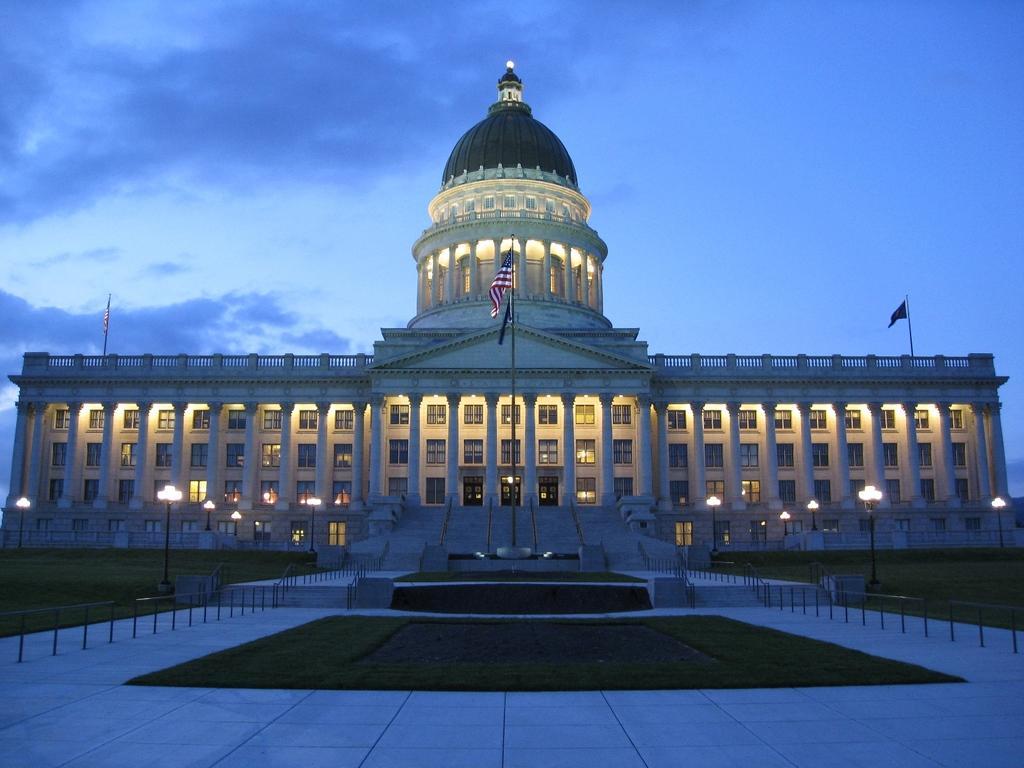Please provide a concise description of this image. In the image we can see there is a ground covered with grass and there are stairs. There is a building and there are street light poles. There are flags and there is a cloudy sky. 